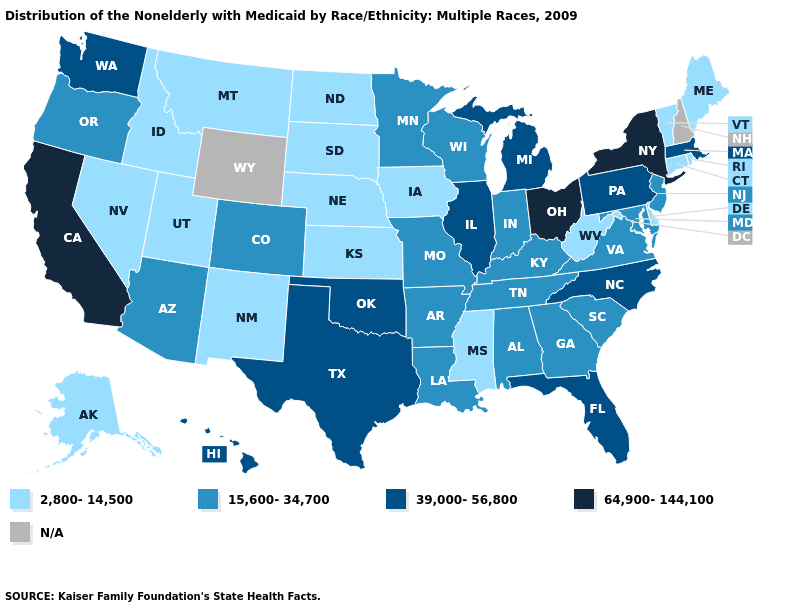Does Oklahoma have the lowest value in the USA?
Quick response, please. No. Name the states that have a value in the range 64,900-144,100?
Write a very short answer. California, New York, Ohio. Among the states that border Missouri , does Tennessee have the highest value?
Short answer required. No. Which states hav the highest value in the South?
Quick response, please. Florida, North Carolina, Oklahoma, Texas. Name the states that have a value in the range 39,000-56,800?
Short answer required. Florida, Hawaii, Illinois, Massachusetts, Michigan, North Carolina, Oklahoma, Pennsylvania, Texas, Washington. Which states have the lowest value in the Northeast?
Write a very short answer. Connecticut, Maine, Rhode Island, Vermont. How many symbols are there in the legend?
Be succinct. 5. Name the states that have a value in the range 64,900-144,100?
Be succinct. California, New York, Ohio. Which states have the highest value in the USA?
Keep it brief. California, New York, Ohio. What is the value of New Hampshire?
Write a very short answer. N/A. Name the states that have a value in the range 2,800-14,500?
Concise answer only. Alaska, Connecticut, Delaware, Idaho, Iowa, Kansas, Maine, Mississippi, Montana, Nebraska, Nevada, New Mexico, North Dakota, Rhode Island, South Dakota, Utah, Vermont, West Virginia. Does Mississippi have the highest value in the South?
Write a very short answer. No. What is the lowest value in the USA?
Quick response, please. 2,800-14,500. 